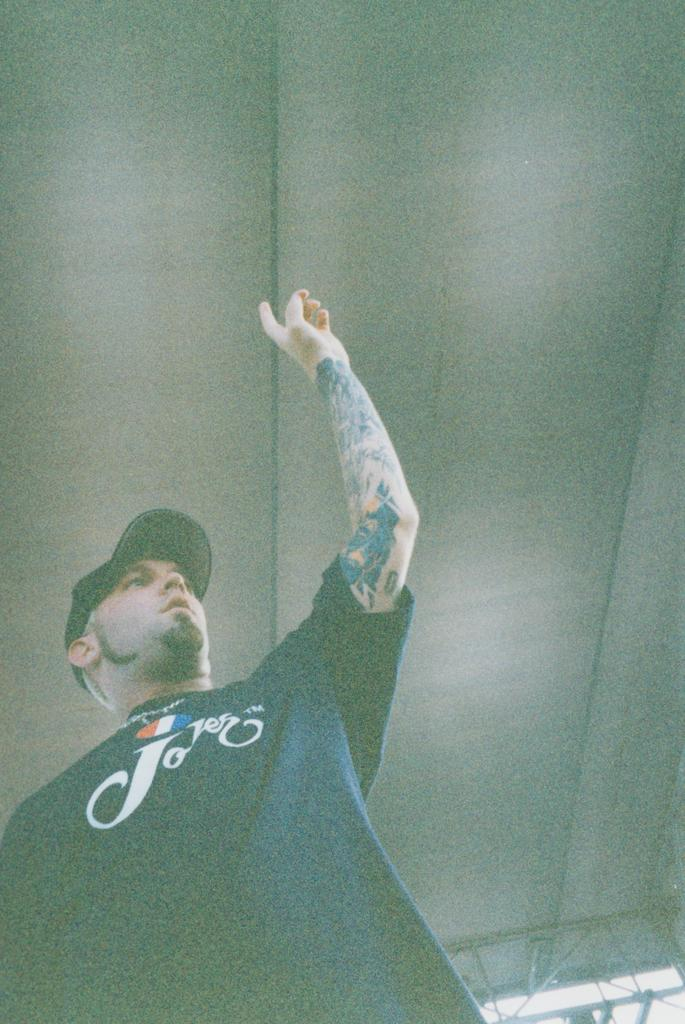Who or what is present in the image? There is a person in the image. What type of structure can be seen in the image? There is a roof visible in the image. How many tubs are visible in the image? There are no tubs present in the image. What type of roll can be seen in the image? There is no roll present in the image. 